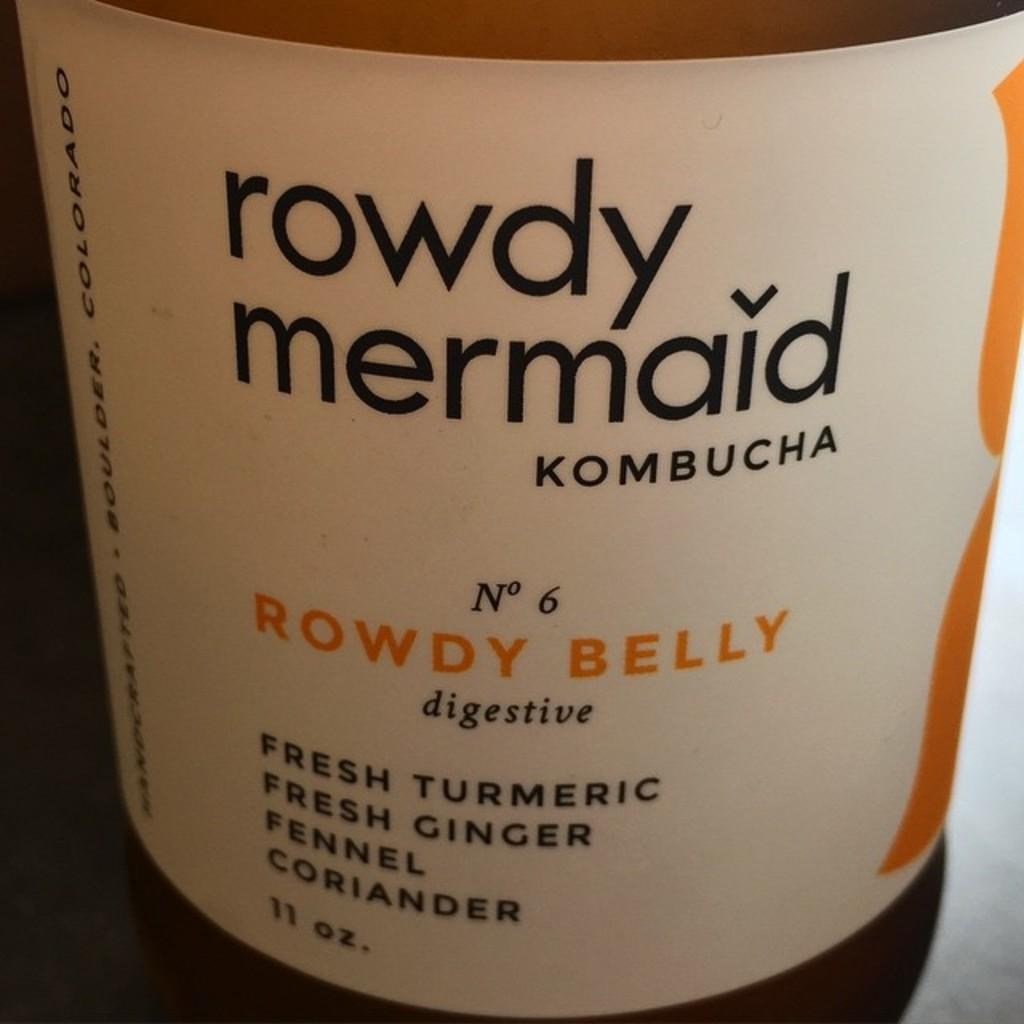<image>
Relay a brief, clear account of the picture shown. An 11 oz bottle of rowdy mermaid kombucha. 